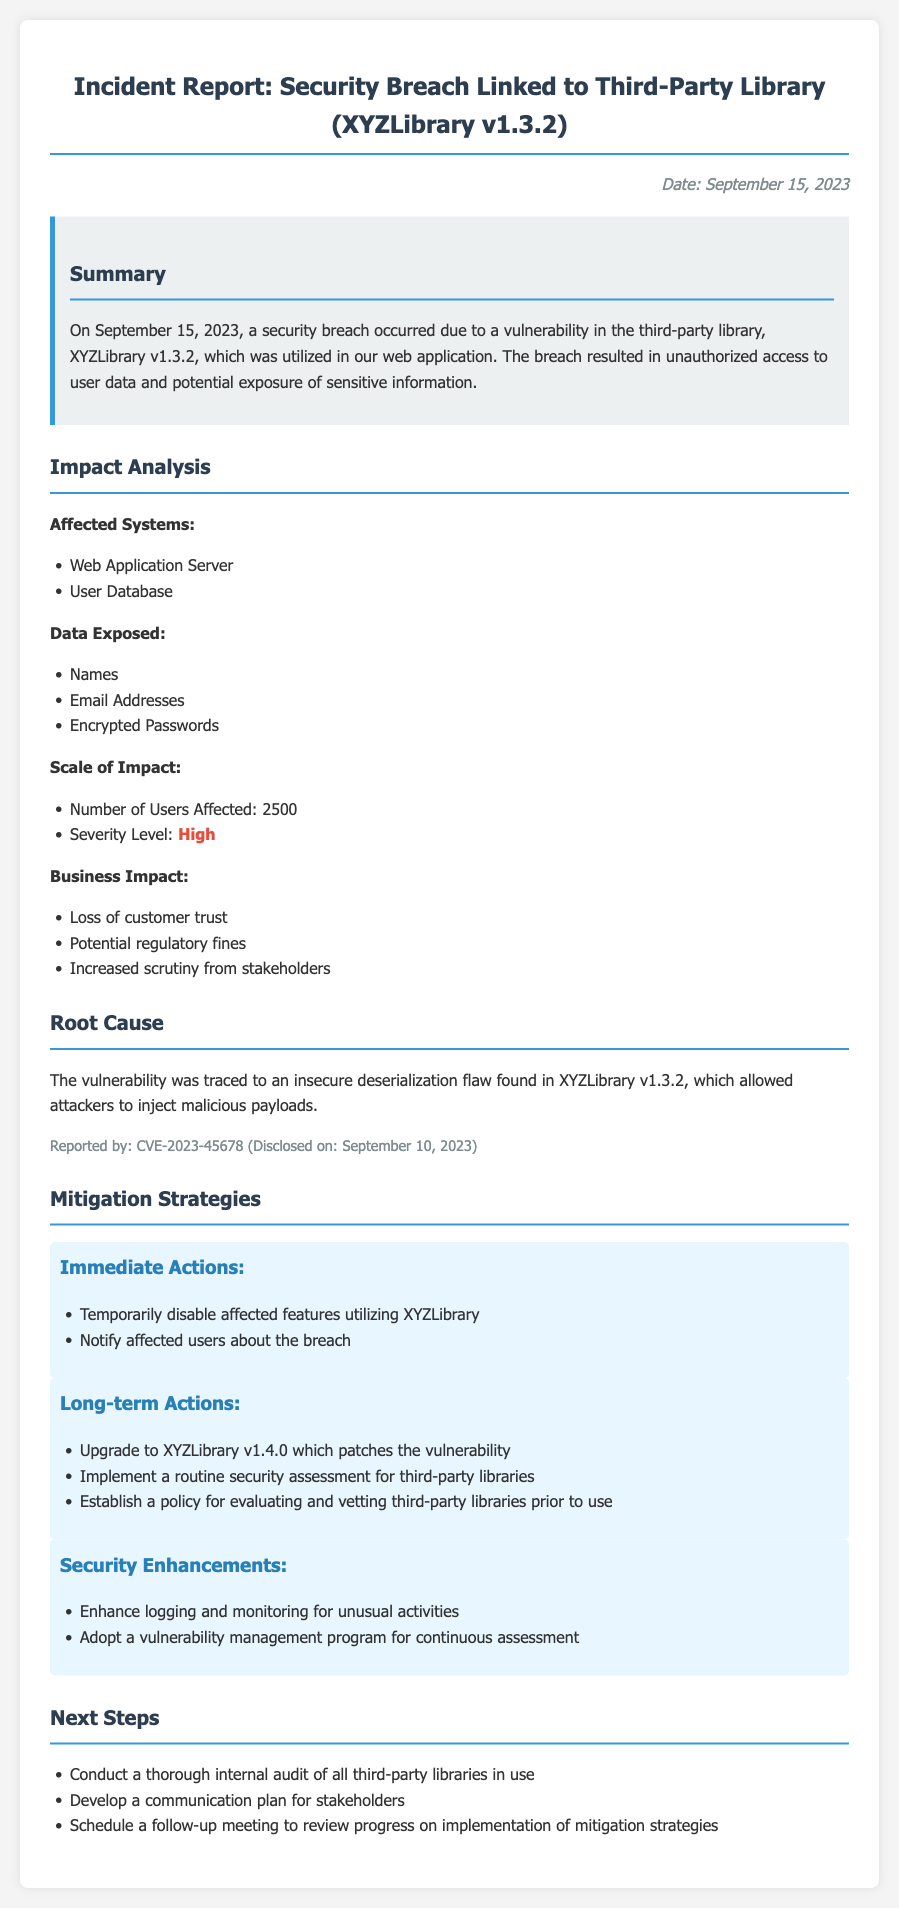What is the date of the incident report? The date of the incident report is mentioned in the document as September 15, 2023.
Answer: September 15, 2023 What third-party library was involved in the breach? The document specifies the third-party library involved as XYZLibrary v1.3.2.
Answer: XYZLibrary v1.3.2 How many users were affected by the security breach? The document states that 2500 users were affected by the breach.
Answer: 2500 What was the severity level of the impact? The severity level of the impact is highlighted as high in the document.
Answer: High What immediate action was taken regarding the affected features? The document mentions the immediate action of temporarily disabling affected features.
Answer: Temporarily disable affected features What flaw was identified in the root cause analysis? The root cause analysis indicates that an insecure deserialization flaw was identified.
Answer: Insecure deserialization flaw What is one long-term action suggested in the mitigation strategies? The document suggests upgrading to XYZLibrary v1.4.0 as a long-term action.
Answer: Upgrade to XYZLibrary v1.4.0 What type of program is recommended for security enhancements? The document recommends adopting a vulnerability management program.
Answer: Vulnerability management program What is one next step listed in the document? One next step listed is conducting a thorough internal audit of all third-party libraries in use.
Answer: Conduct a thorough internal audit 